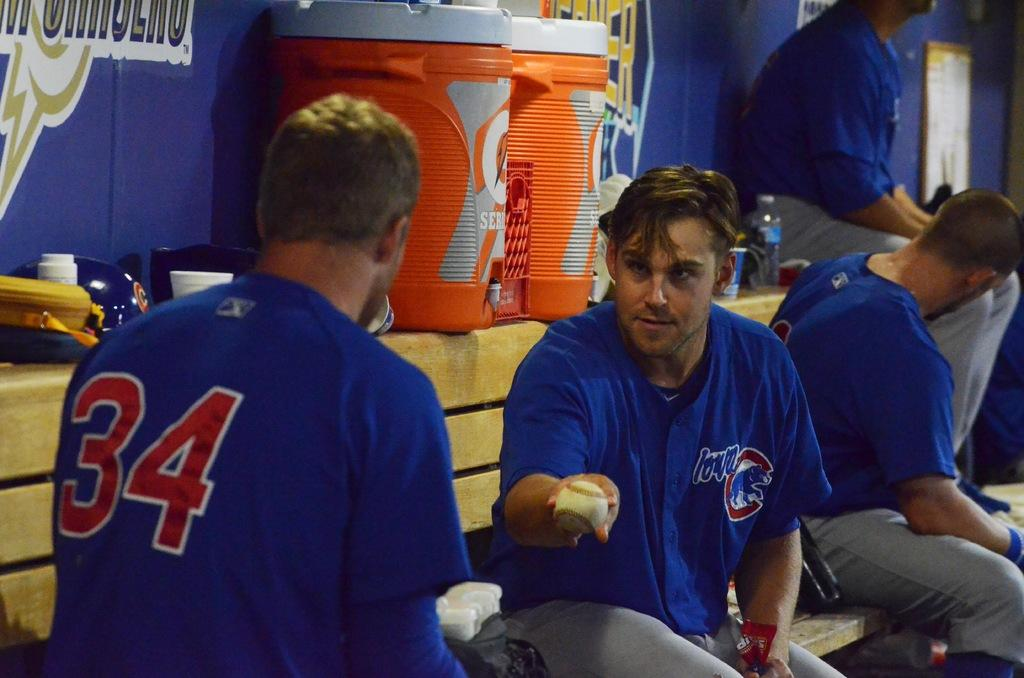Provide a one-sentence caption for the provided image. A baseball player lovingly offer his ball to player number 34. 